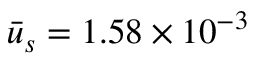Convert formula to latex. <formula><loc_0><loc_0><loc_500><loc_500>\bar { u } _ { s } = 1 . 5 8 \times { 1 0 ^ { - 3 } }</formula> 